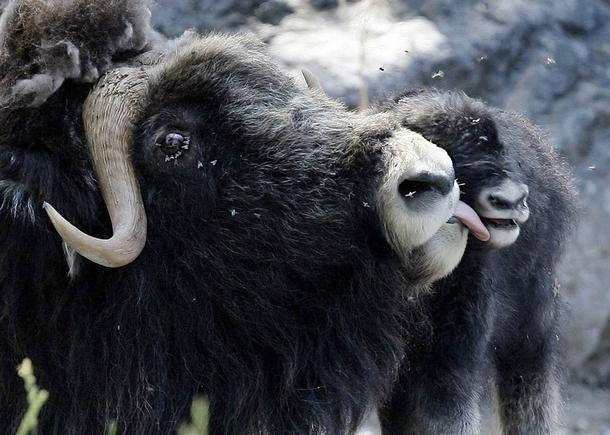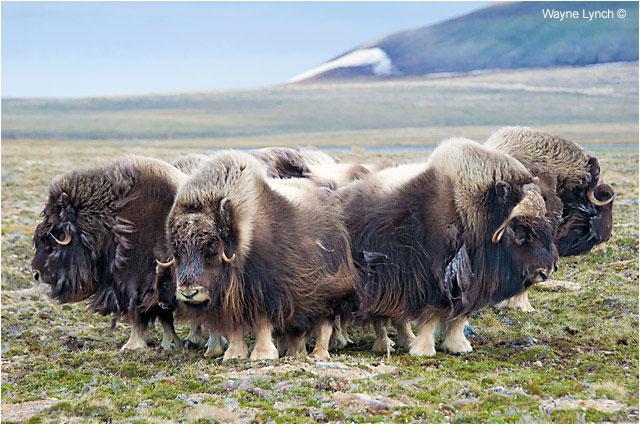The first image is the image on the left, the second image is the image on the right. Analyze the images presented: Is the assertion "There are no more than three yaks in the left image." valid? Answer yes or no. Yes. The first image is the image on the left, the second image is the image on the right. Considering the images on both sides, is "At least one image shows a group of buffalo-type animals standing on non-snowy ground." valid? Answer yes or no. Yes. 